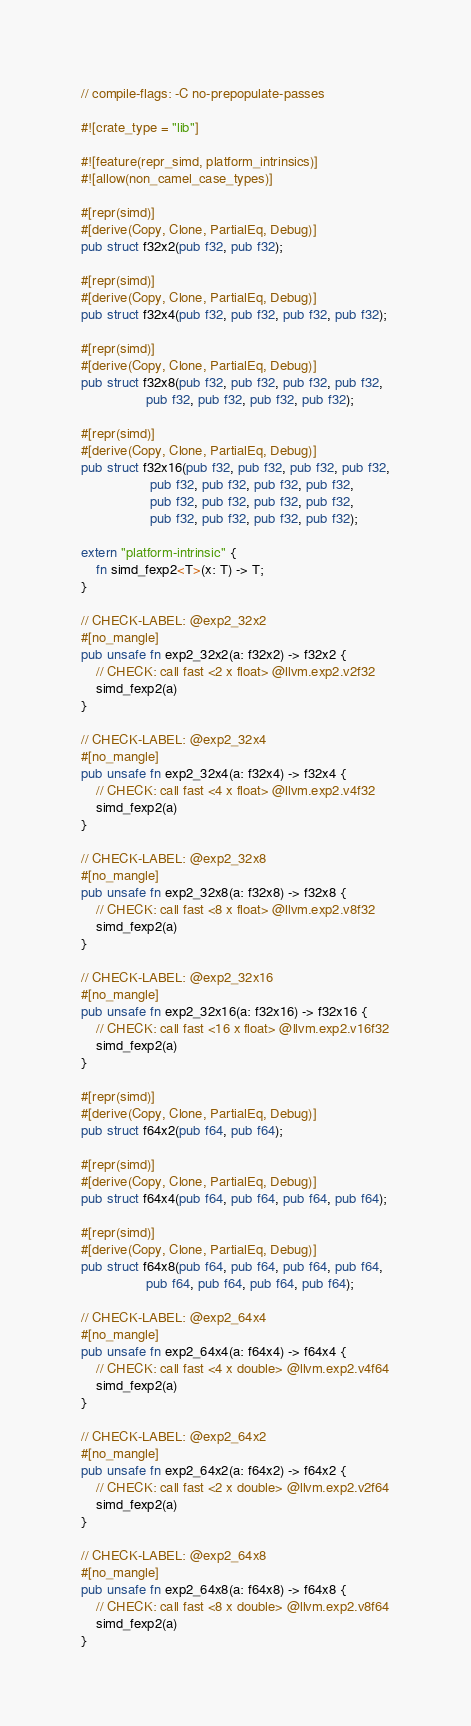Convert code to text. <code><loc_0><loc_0><loc_500><loc_500><_Rust_>// compile-flags: -C no-prepopulate-passes

#![crate_type = "lib"]

#![feature(repr_simd, platform_intrinsics)]
#![allow(non_camel_case_types)]

#[repr(simd)]
#[derive(Copy, Clone, PartialEq, Debug)]
pub struct f32x2(pub f32, pub f32);

#[repr(simd)]
#[derive(Copy, Clone, PartialEq, Debug)]
pub struct f32x4(pub f32, pub f32, pub f32, pub f32);

#[repr(simd)]
#[derive(Copy, Clone, PartialEq, Debug)]
pub struct f32x8(pub f32, pub f32, pub f32, pub f32,
                 pub f32, pub f32, pub f32, pub f32);

#[repr(simd)]
#[derive(Copy, Clone, PartialEq, Debug)]
pub struct f32x16(pub f32, pub f32, pub f32, pub f32,
                  pub f32, pub f32, pub f32, pub f32,
                  pub f32, pub f32, pub f32, pub f32,
                  pub f32, pub f32, pub f32, pub f32);

extern "platform-intrinsic" {
    fn simd_fexp2<T>(x: T) -> T;
}

// CHECK-LABEL: @exp2_32x2
#[no_mangle]
pub unsafe fn exp2_32x2(a: f32x2) -> f32x2 {
    // CHECK: call fast <2 x float> @llvm.exp2.v2f32
    simd_fexp2(a)
}

// CHECK-LABEL: @exp2_32x4
#[no_mangle]
pub unsafe fn exp2_32x4(a: f32x4) -> f32x4 {
    // CHECK: call fast <4 x float> @llvm.exp2.v4f32
    simd_fexp2(a)
}

// CHECK-LABEL: @exp2_32x8
#[no_mangle]
pub unsafe fn exp2_32x8(a: f32x8) -> f32x8 {
    // CHECK: call fast <8 x float> @llvm.exp2.v8f32
    simd_fexp2(a)
}

// CHECK-LABEL: @exp2_32x16
#[no_mangle]
pub unsafe fn exp2_32x16(a: f32x16) -> f32x16 {
    // CHECK: call fast <16 x float> @llvm.exp2.v16f32
    simd_fexp2(a)
}

#[repr(simd)]
#[derive(Copy, Clone, PartialEq, Debug)]
pub struct f64x2(pub f64, pub f64);

#[repr(simd)]
#[derive(Copy, Clone, PartialEq, Debug)]
pub struct f64x4(pub f64, pub f64, pub f64, pub f64);

#[repr(simd)]
#[derive(Copy, Clone, PartialEq, Debug)]
pub struct f64x8(pub f64, pub f64, pub f64, pub f64,
                 pub f64, pub f64, pub f64, pub f64);

// CHECK-LABEL: @exp2_64x4
#[no_mangle]
pub unsafe fn exp2_64x4(a: f64x4) -> f64x4 {
    // CHECK: call fast <4 x double> @llvm.exp2.v4f64
    simd_fexp2(a)
}

// CHECK-LABEL: @exp2_64x2
#[no_mangle]
pub unsafe fn exp2_64x2(a: f64x2) -> f64x2 {
    // CHECK: call fast <2 x double> @llvm.exp2.v2f64
    simd_fexp2(a)
}

// CHECK-LABEL: @exp2_64x8
#[no_mangle]
pub unsafe fn exp2_64x8(a: f64x8) -> f64x8 {
    // CHECK: call fast <8 x double> @llvm.exp2.v8f64
    simd_fexp2(a)
}
</code> 